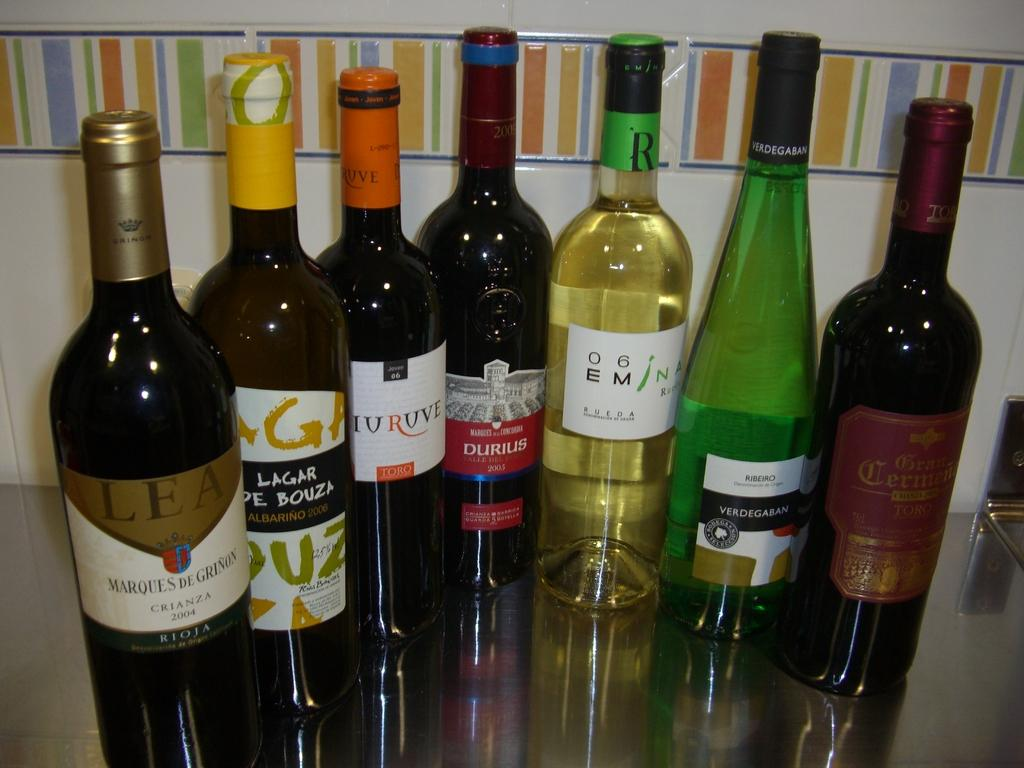<image>
Offer a succinct explanation of the picture presented. A number of bottles of wine are displayed, with dates as early as 2004 